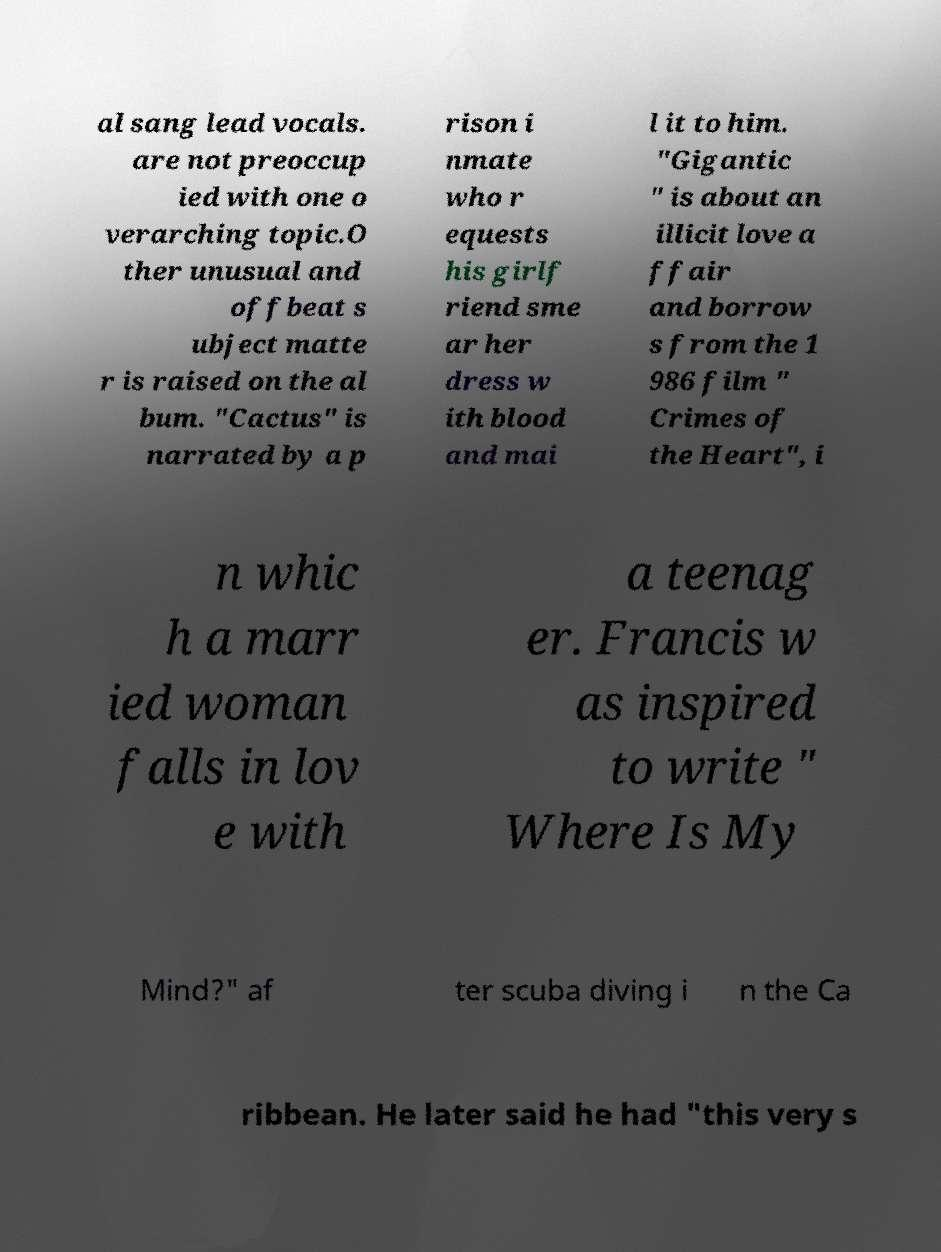I need the written content from this picture converted into text. Can you do that? al sang lead vocals. are not preoccup ied with one o verarching topic.O ther unusual and offbeat s ubject matte r is raised on the al bum. "Cactus" is narrated by a p rison i nmate who r equests his girlf riend sme ar her dress w ith blood and mai l it to him. "Gigantic " is about an illicit love a ffair and borrow s from the 1 986 film " Crimes of the Heart", i n whic h a marr ied woman falls in lov e with a teenag er. Francis w as inspired to write " Where Is My Mind?" af ter scuba diving i n the Ca ribbean. He later said he had "this very s 